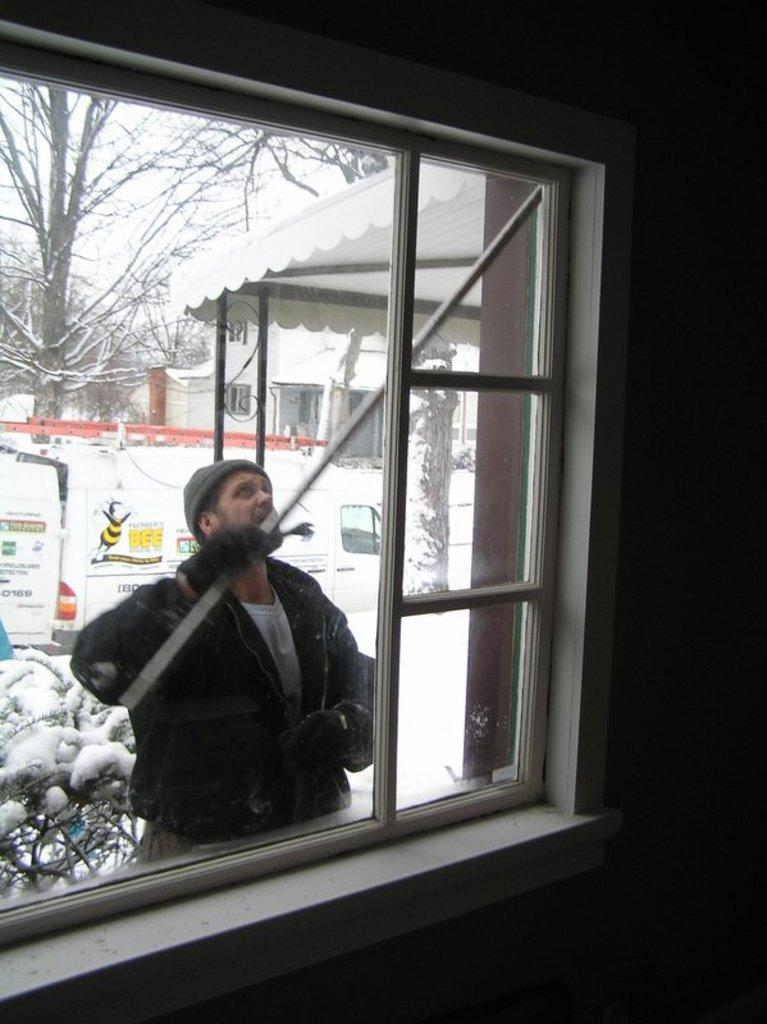What is the main subject of the image? There is a man standing in the middle of the image. What is the man wearing? The man is wearing a coat. What can be seen in the background of the image? There is a window in the image. What type of vegetation is on the left side of the image? There is a tree on the left side of the image. What type of attraction can be seen in the image? There is no attraction present in the image; it features a man standing in the middle, wearing a coat, with a window in the background and a tree on the left side. How many geese are visible in the image? There are no geese present in the image. 